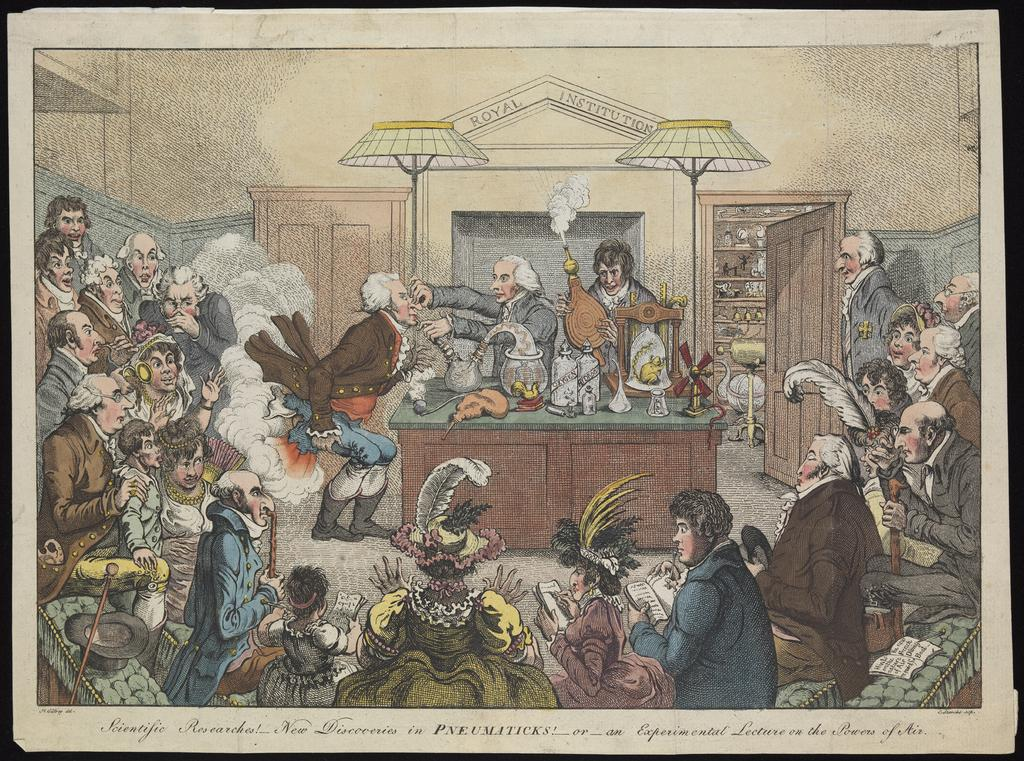<image>
Give a short and clear explanation of the subsequent image. A photo of men and women sitting in a victorian court reads "Scientific Researches!" at the bottom 